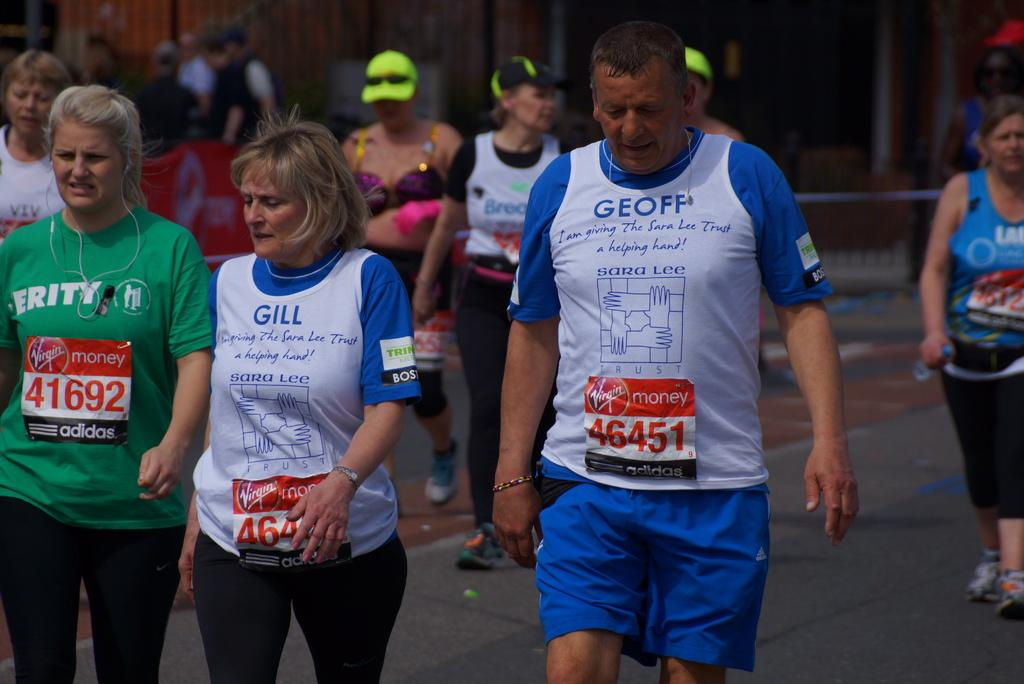<image>
Relay a brief, clear account of the picture shown. People are walking in a marathon and their numbered stickers say Virgin Money on them. 